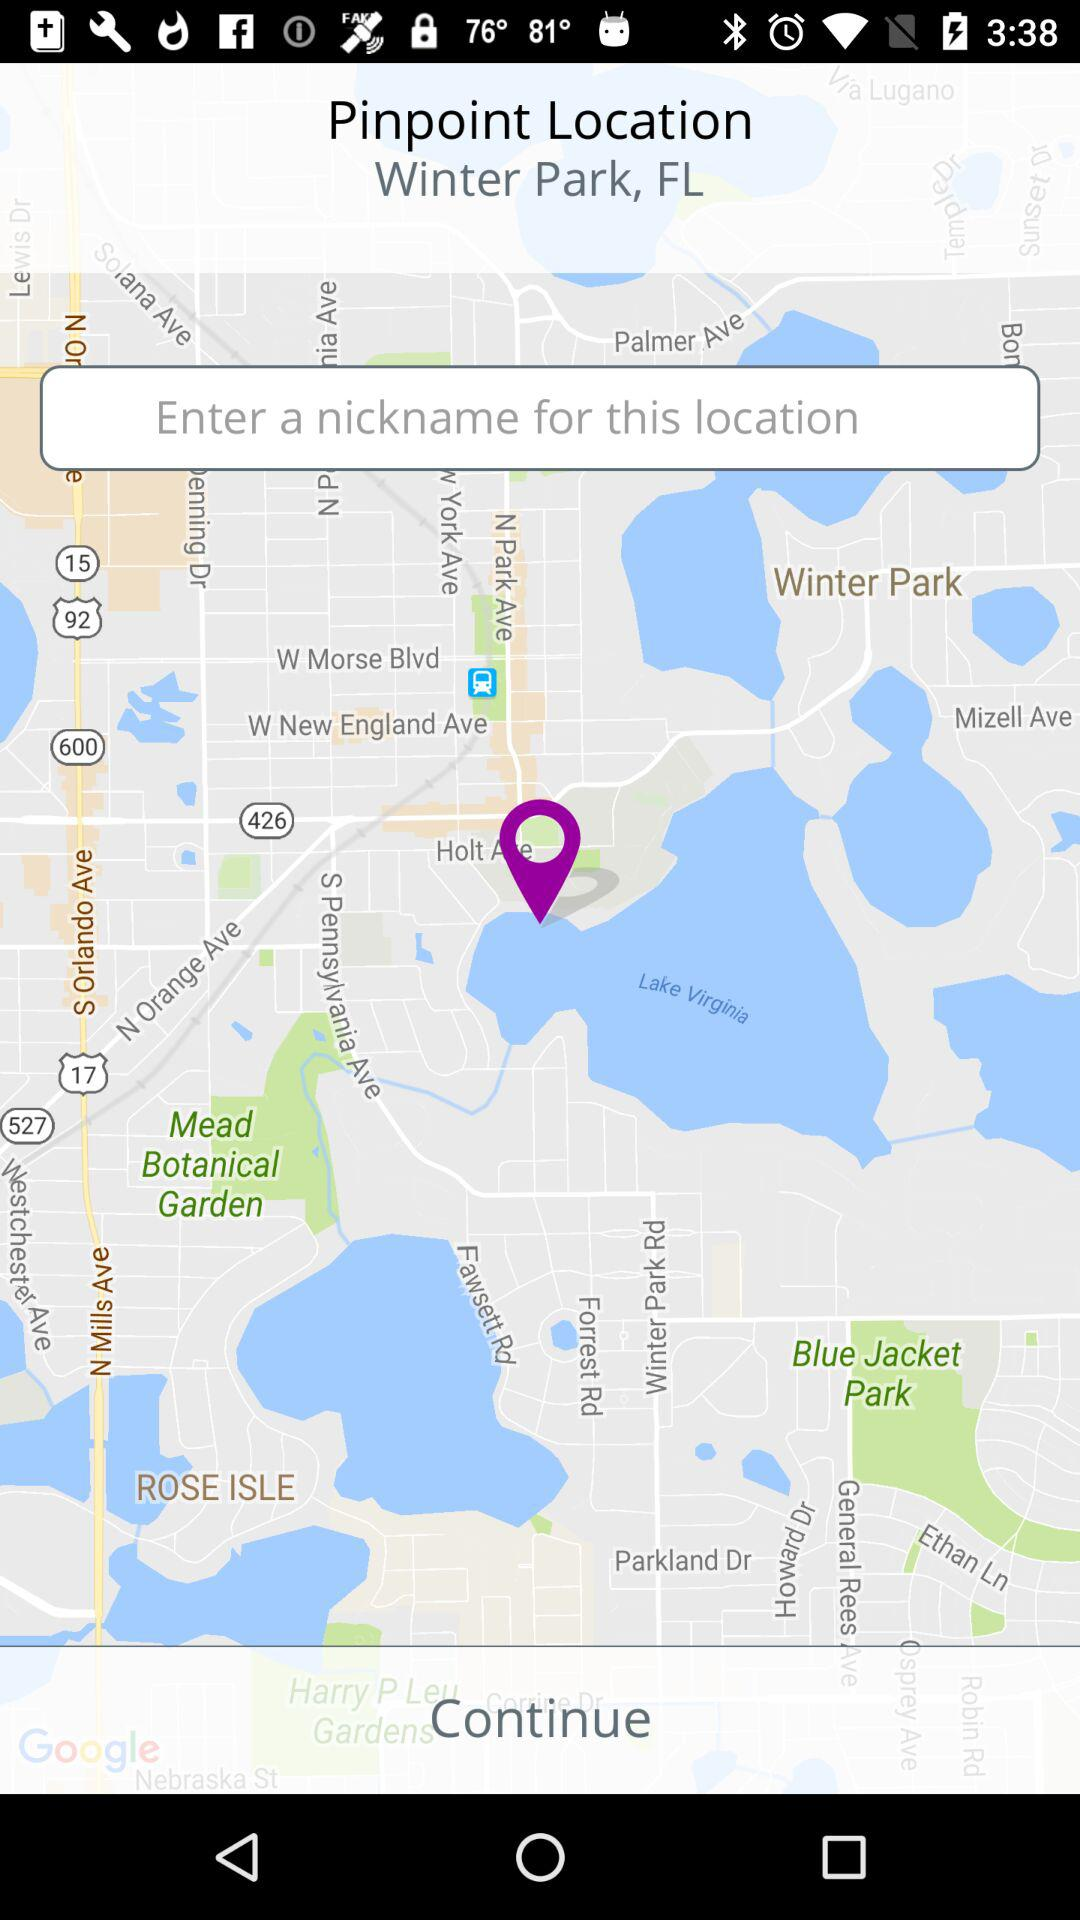What is the application name?
When the provided information is insufficient, respond with <no answer>. <no answer> 